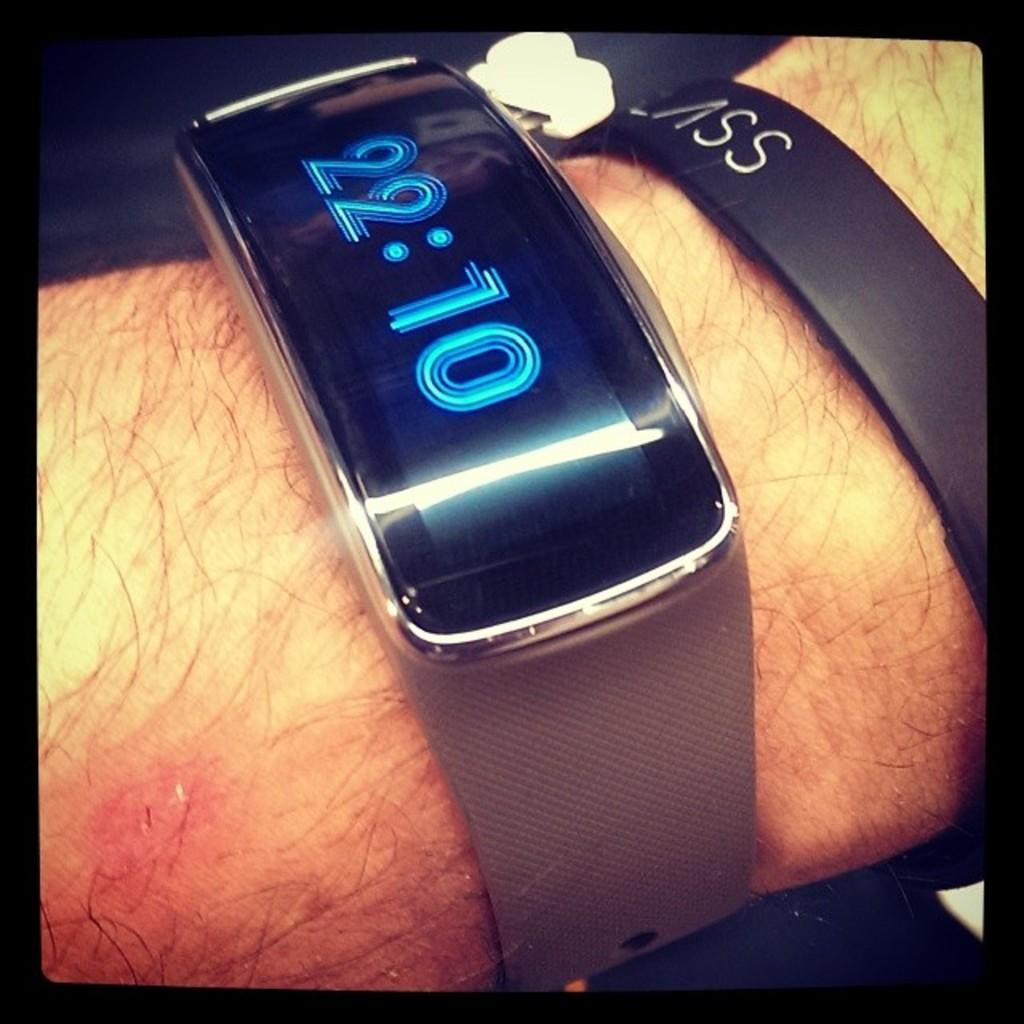<image>
Share a concise interpretation of the image provided. Large rose gold metallic smart watch with wrist-sized rectangular display, black screen with light blue numbering showing time to be 22:10. 